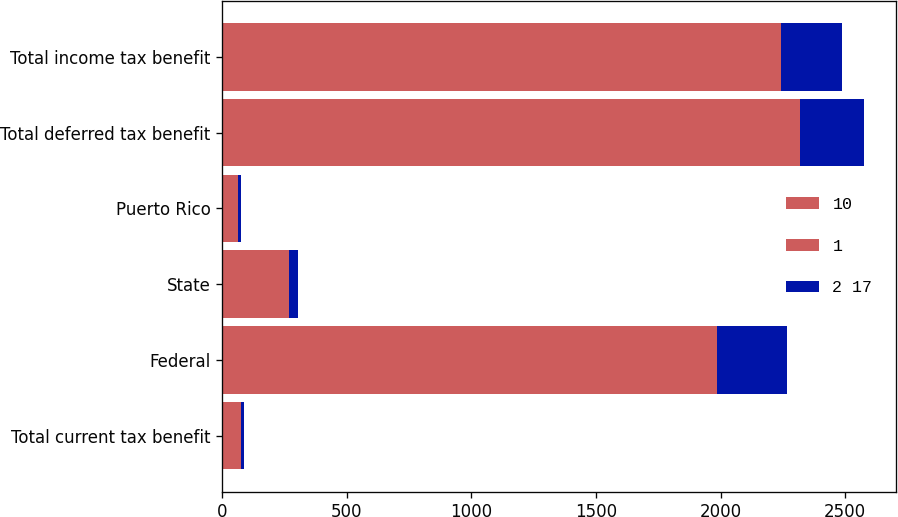<chart> <loc_0><loc_0><loc_500><loc_500><stacked_bar_chart><ecel><fcel>Total current tax benefit<fcel>Federal<fcel>State<fcel>Puerto Rico<fcel>Total deferred tax benefit<fcel>Total income tax benefit<nl><fcel>10<fcel>29<fcel>1182<fcel>173<fcel>49<fcel>1404<fcel>1375<nl><fcel>1<fcel>47<fcel>804<fcel>96<fcel>14<fcel>914<fcel>867<nl><fcel>2 17<fcel>11<fcel>281<fcel>37<fcel>12<fcel>256<fcel>245<nl></chart> 